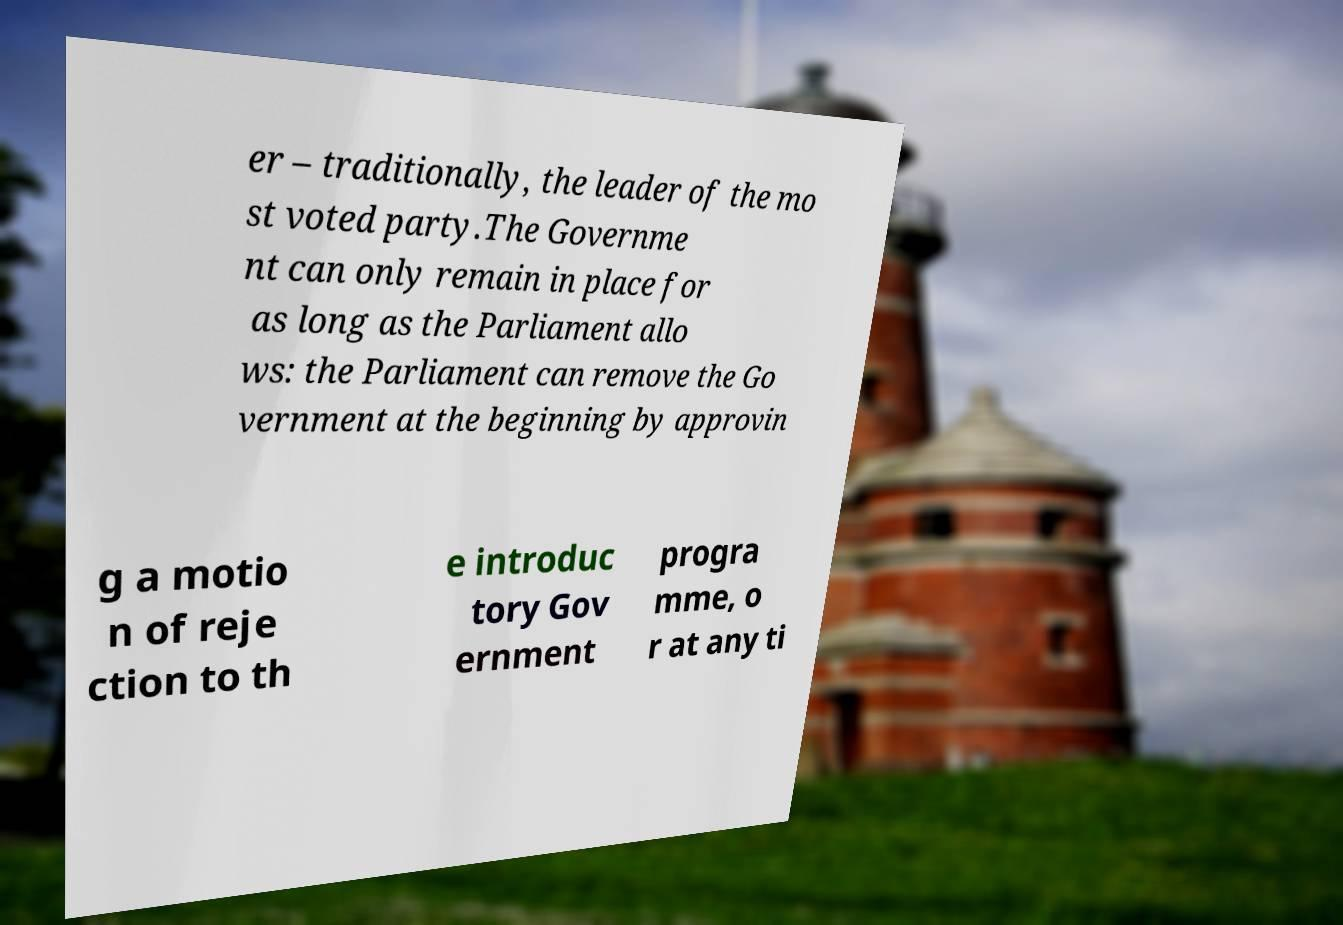Could you assist in decoding the text presented in this image and type it out clearly? er – traditionally, the leader of the mo st voted party.The Governme nt can only remain in place for as long as the Parliament allo ws: the Parliament can remove the Go vernment at the beginning by approvin g a motio n of reje ction to th e introduc tory Gov ernment progra mme, o r at any ti 